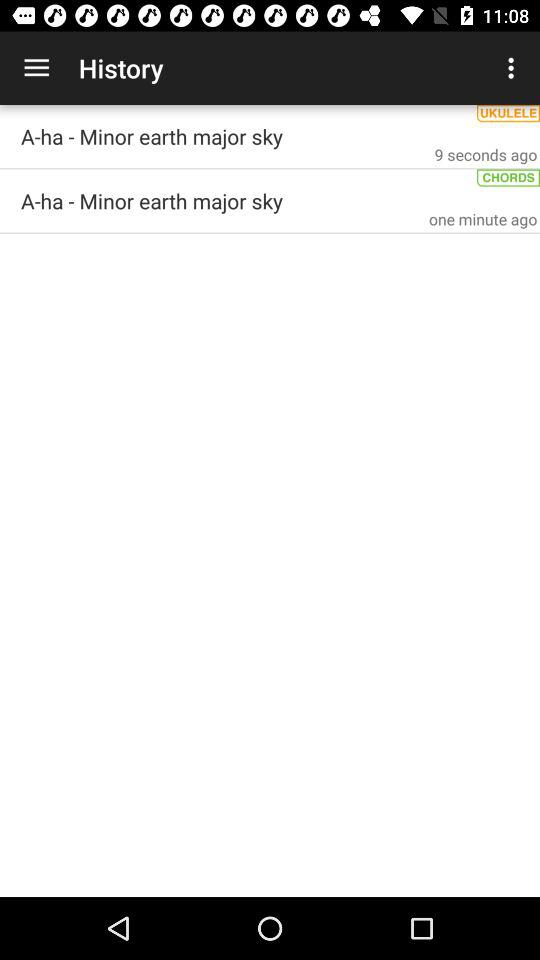What was updated 9 seconds ago? The item that was updated 9 seconds ago was "A-ha - Minor earth major sky". 